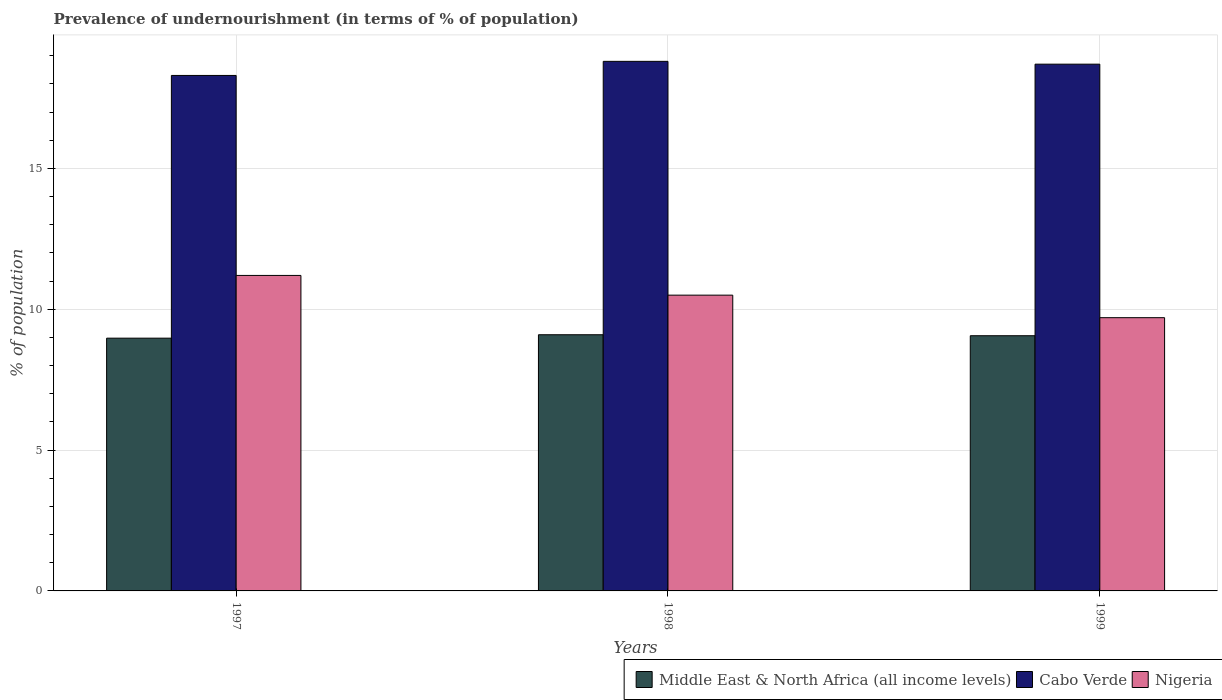How many different coloured bars are there?
Your answer should be compact. 3. Are the number of bars on each tick of the X-axis equal?
Your response must be concise. Yes. How many bars are there on the 2nd tick from the left?
Provide a short and direct response. 3. What is the label of the 2nd group of bars from the left?
Keep it short and to the point. 1998. What is the percentage of undernourished population in Middle East & North Africa (all income levels) in 1997?
Provide a succinct answer. 8.97. Across all years, what is the maximum percentage of undernourished population in Middle East & North Africa (all income levels)?
Make the answer very short. 9.09. In which year was the percentage of undernourished population in Nigeria maximum?
Offer a very short reply. 1997. What is the total percentage of undernourished population in Cabo Verde in the graph?
Provide a short and direct response. 55.8. What is the difference between the percentage of undernourished population in Nigeria in 1998 and that in 1999?
Keep it short and to the point. 0.8. What is the difference between the percentage of undernourished population in Middle East & North Africa (all income levels) in 1997 and the percentage of undernourished population in Cabo Verde in 1999?
Your response must be concise. -9.73. What is the average percentage of undernourished population in Nigeria per year?
Provide a succinct answer. 10.47. In the year 1999, what is the difference between the percentage of undernourished population in Middle East & North Africa (all income levels) and percentage of undernourished population in Nigeria?
Your answer should be compact. -0.64. In how many years, is the percentage of undernourished population in Cabo Verde greater than 15 %?
Provide a succinct answer. 3. What is the ratio of the percentage of undernourished population in Nigeria in 1997 to that in 1998?
Keep it short and to the point. 1.07. Is the difference between the percentage of undernourished population in Middle East & North Africa (all income levels) in 1998 and 1999 greater than the difference between the percentage of undernourished population in Nigeria in 1998 and 1999?
Your answer should be very brief. No. What is the difference between the highest and the second highest percentage of undernourished population in Middle East & North Africa (all income levels)?
Your answer should be very brief. 0.04. What is the difference between the highest and the lowest percentage of undernourished population in Middle East & North Africa (all income levels)?
Provide a succinct answer. 0.12. What does the 3rd bar from the left in 1998 represents?
Keep it short and to the point. Nigeria. What does the 3rd bar from the right in 1999 represents?
Give a very brief answer. Middle East & North Africa (all income levels). Are all the bars in the graph horizontal?
Your answer should be compact. No. How many years are there in the graph?
Provide a short and direct response. 3. Are the values on the major ticks of Y-axis written in scientific E-notation?
Give a very brief answer. No. Does the graph contain any zero values?
Your response must be concise. No. Does the graph contain grids?
Give a very brief answer. Yes. Where does the legend appear in the graph?
Provide a succinct answer. Bottom right. What is the title of the graph?
Your answer should be very brief. Prevalence of undernourishment (in terms of % of population). Does "Dominican Republic" appear as one of the legend labels in the graph?
Your answer should be compact. No. What is the label or title of the X-axis?
Keep it short and to the point. Years. What is the label or title of the Y-axis?
Your answer should be very brief. % of population. What is the % of population in Middle East & North Africa (all income levels) in 1997?
Keep it short and to the point. 8.97. What is the % of population in Middle East & North Africa (all income levels) in 1998?
Your answer should be compact. 9.09. What is the % of population of Cabo Verde in 1998?
Keep it short and to the point. 18.8. What is the % of population of Nigeria in 1998?
Provide a short and direct response. 10.5. What is the % of population of Middle East & North Africa (all income levels) in 1999?
Make the answer very short. 9.06. What is the % of population in Cabo Verde in 1999?
Your response must be concise. 18.7. What is the % of population of Nigeria in 1999?
Give a very brief answer. 9.7. Across all years, what is the maximum % of population of Middle East & North Africa (all income levels)?
Your answer should be very brief. 9.09. Across all years, what is the minimum % of population of Middle East & North Africa (all income levels)?
Offer a very short reply. 8.97. Across all years, what is the minimum % of population of Cabo Verde?
Provide a succinct answer. 18.3. What is the total % of population in Middle East & North Africa (all income levels) in the graph?
Your response must be concise. 27.13. What is the total % of population in Cabo Verde in the graph?
Give a very brief answer. 55.8. What is the total % of population in Nigeria in the graph?
Your answer should be compact. 31.4. What is the difference between the % of population in Middle East & North Africa (all income levels) in 1997 and that in 1998?
Provide a short and direct response. -0.12. What is the difference between the % of population of Middle East & North Africa (all income levels) in 1997 and that in 1999?
Your answer should be compact. -0.09. What is the difference between the % of population in Nigeria in 1997 and that in 1999?
Make the answer very short. 1.5. What is the difference between the % of population in Middle East & North Africa (all income levels) in 1998 and that in 1999?
Offer a terse response. 0.04. What is the difference between the % of population of Cabo Verde in 1998 and that in 1999?
Your answer should be compact. 0.1. What is the difference between the % of population of Middle East & North Africa (all income levels) in 1997 and the % of population of Cabo Verde in 1998?
Offer a terse response. -9.83. What is the difference between the % of population of Middle East & North Africa (all income levels) in 1997 and the % of population of Nigeria in 1998?
Keep it short and to the point. -1.53. What is the difference between the % of population in Middle East & North Africa (all income levels) in 1997 and the % of population in Cabo Verde in 1999?
Give a very brief answer. -9.73. What is the difference between the % of population of Middle East & North Africa (all income levels) in 1997 and the % of population of Nigeria in 1999?
Make the answer very short. -0.73. What is the difference between the % of population of Cabo Verde in 1997 and the % of population of Nigeria in 1999?
Make the answer very short. 8.6. What is the difference between the % of population in Middle East & North Africa (all income levels) in 1998 and the % of population in Cabo Verde in 1999?
Provide a succinct answer. -9.61. What is the difference between the % of population in Middle East & North Africa (all income levels) in 1998 and the % of population in Nigeria in 1999?
Your answer should be compact. -0.61. What is the difference between the % of population in Cabo Verde in 1998 and the % of population in Nigeria in 1999?
Provide a short and direct response. 9.1. What is the average % of population in Middle East & North Africa (all income levels) per year?
Offer a very short reply. 9.04. What is the average % of population of Cabo Verde per year?
Your answer should be compact. 18.6. What is the average % of population in Nigeria per year?
Provide a short and direct response. 10.47. In the year 1997, what is the difference between the % of population of Middle East & North Africa (all income levels) and % of population of Cabo Verde?
Offer a terse response. -9.33. In the year 1997, what is the difference between the % of population in Middle East & North Africa (all income levels) and % of population in Nigeria?
Provide a short and direct response. -2.23. In the year 1998, what is the difference between the % of population in Middle East & North Africa (all income levels) and % of population in Cabo Verde?
Keep it short and to the point. -9.71. In the year 1998, what is the difference between the % of population in Middle East & North Africa (all income levels) and % of population in Nigeria?
Provide a succinct answer. -1.41. In the year 1998, what is the difference between the % of population of Cabo Verde and % of population of Nigeria?
Offer a very short reply. 8.3. In the year 1999, what is the difference between the % of population of Middle East & North Africa (all income levels) and % of population of Cabo Verde?
Keep it short and to the point. -9.64. In the year 1999, what is the difference between the % of population in Middle East & North Africa (all income levels) and % of population in Nigeria?
Offer a very short reply. -0.64. In the year 1999, what is the difference between the % of population of Cabo Verde and % of population of Nigeria?
Your response must be concise. 9. What is the ratio of the % of population in Middle East & North Africa (all income levels) in 1997 to that in 1998?
Provide a succinct answer. 0.99. What is the ratio of the % of population in Cabo Verde in 1997 to that in 1998?
Your answer should be very brief. 0.97. What is the ratio of the % of population in Nigeria in 1997 to that in 1998?
Your answer should be compact. 1.07. What is the ratio of the % of population of Cabo Verde in 1997 to that in 1999?
Offer a very short reply. 0.98. What is the ratio of the % of population of Nigeria in 1997 to that in 1999?
Offer a terse response. 1.15. What is the ratio of the % of population in Middle East & North Africa (all income levels) in 1998 to that in 1999?
Make the answer very short. 1. What is the ratio of the % of population of Nigeria in 1998 to that in 1999?
Keep it short and to the point. 1.08. What is the difference between the highest and the second highest % of population of Middle East & North Africa (all income levels)?
Your answer should be very brief. 0.04. What is the difference between the highest and the lowest % of population of Middle East & North Africa (all income levels)?
Give a very brief answer. 0.12. What is the difference between the highest and the lowest % of population in Nigeria?
Your answer should be compact. 1.5. 